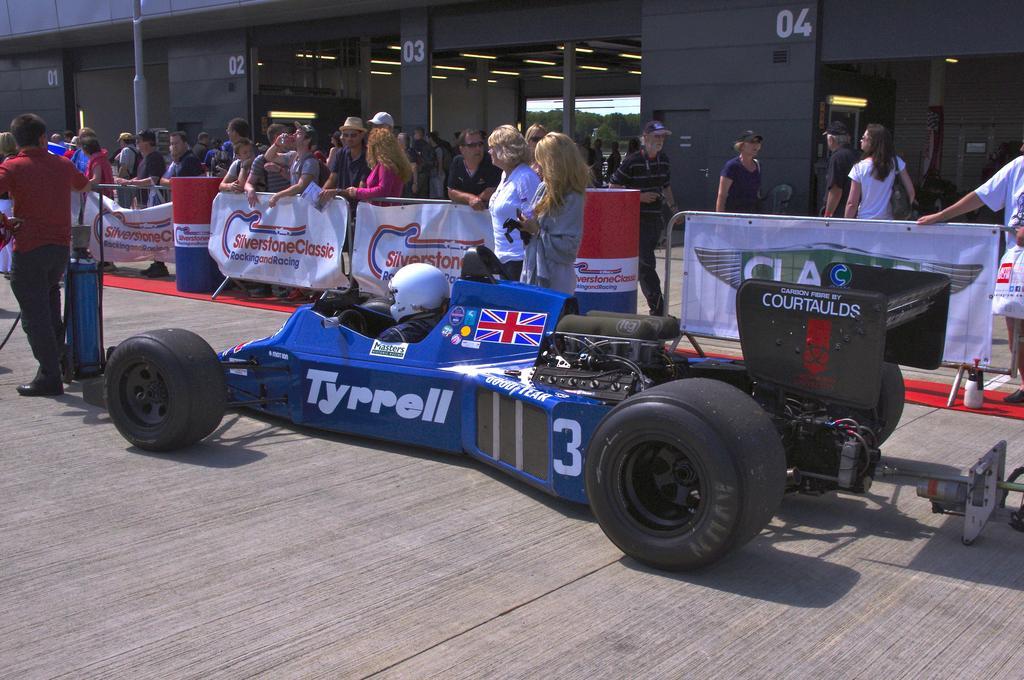In one or two sentences, can you explain what this image depicts? In the foreground of this image, there is a sports car on the road. On the left, there is a man standing near an object. Behind the car, there are people walking and standing, few boards and bollard like objects. In the background, there is a building. 